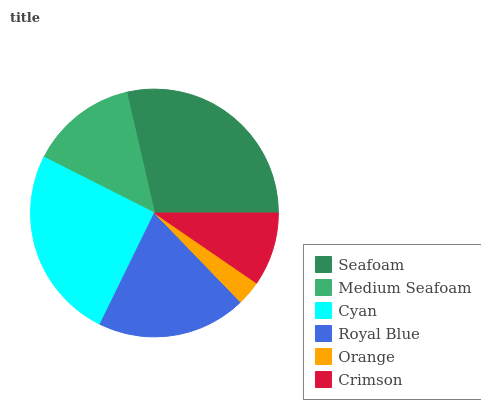Is Orange the minimum?
Answer yes or no. Yes. Is Seafoam the maximum?
Answer yes or no. Yes. Is Medium Seafoam the minimum?
Answer yes or no. No. Is Medium Seafoam the maximum?
Answer yes or no. No. Is Seafoam greater than Medium Seafoam?
Answer yes or no. Yes. Is Medium Seafoam less than Seafoam?
Answer yes or no. Yes. Is Medium Seafoam greater than Seafoam?
Answer yes or no. No. Is Seafoam less than Medium Seafoam?
Answer yes or no. No. Is Royal Blue the high median?
Answer yes or no. Yes. Is Medium Seafoam the low median?
Answer yes or no. Yes. Is Seafoam the high median?
Answer yes or no. No. Is Cyan the low median?
Answer yes or no. No. 